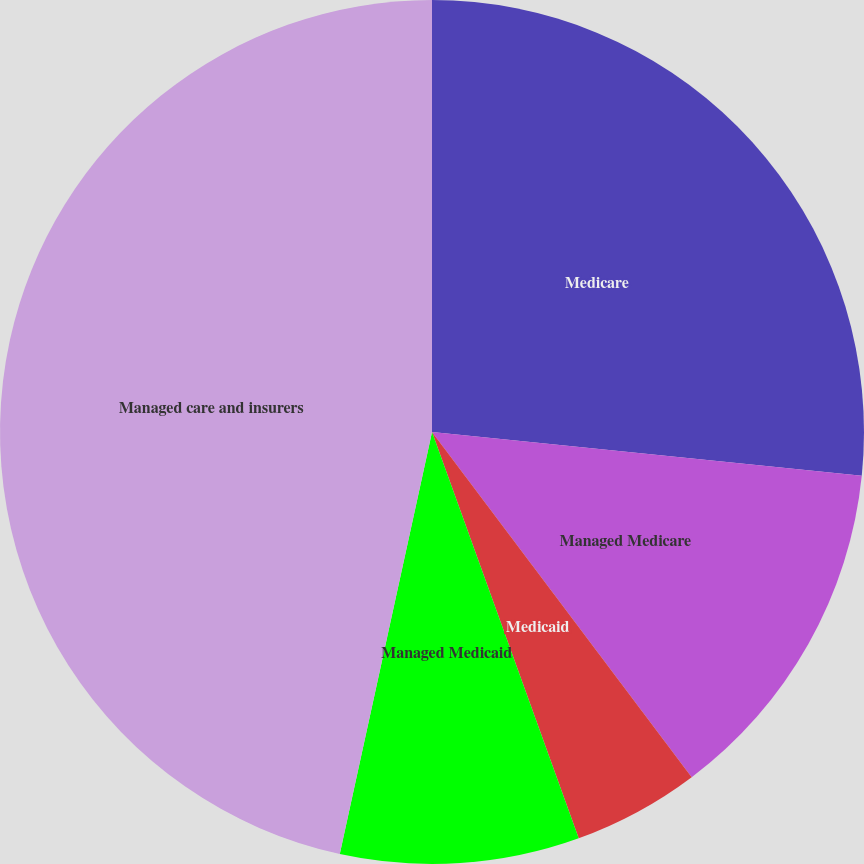Convert chart. <chart><loc_0><loc_0><loc_500><loc_500><pie_chart><fcel>Medicare<fcel>Managed Medicare<fcel>Medicaid<fcel>Managed Medicaid<fcel>Managed care and insurers<nl><fcel>26.62%<fcel>13.12%<fcel>4.75%<fcel>8.94%<fcel>46.58%<nl></chart> 